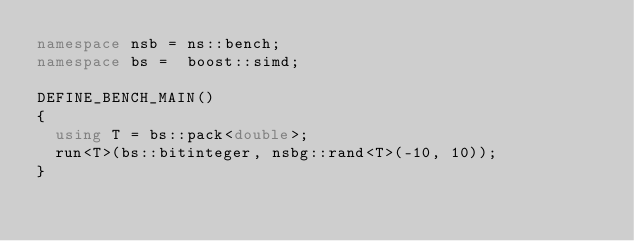Convert code to text. <code><loc_0><loc_0><loc_500><loc_500><_C++_>namespace nsb = ns::bench;
namespace bs =  boost::simd;

DEFINE_BENCH_MAIN()
{
  using T = bs::pack<double>;
  run<T>(bs::bitinteger, nsbg::rand<T>(-10, 10));
}
</code> 